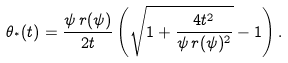Convert formula to latex. <formula><loc_0><loc_0><loc_500><loc_500>\theta _ { ^ { * } } ( t ) = \frac { \psi \, r ( \psi ) } { 2 t } \left ( \sqrt { 1 + \frac { 4 t ^ { 2 } } { \psi \, r ( \psi ) ^ { 2 } } } - 1 \right ) .</formula> 